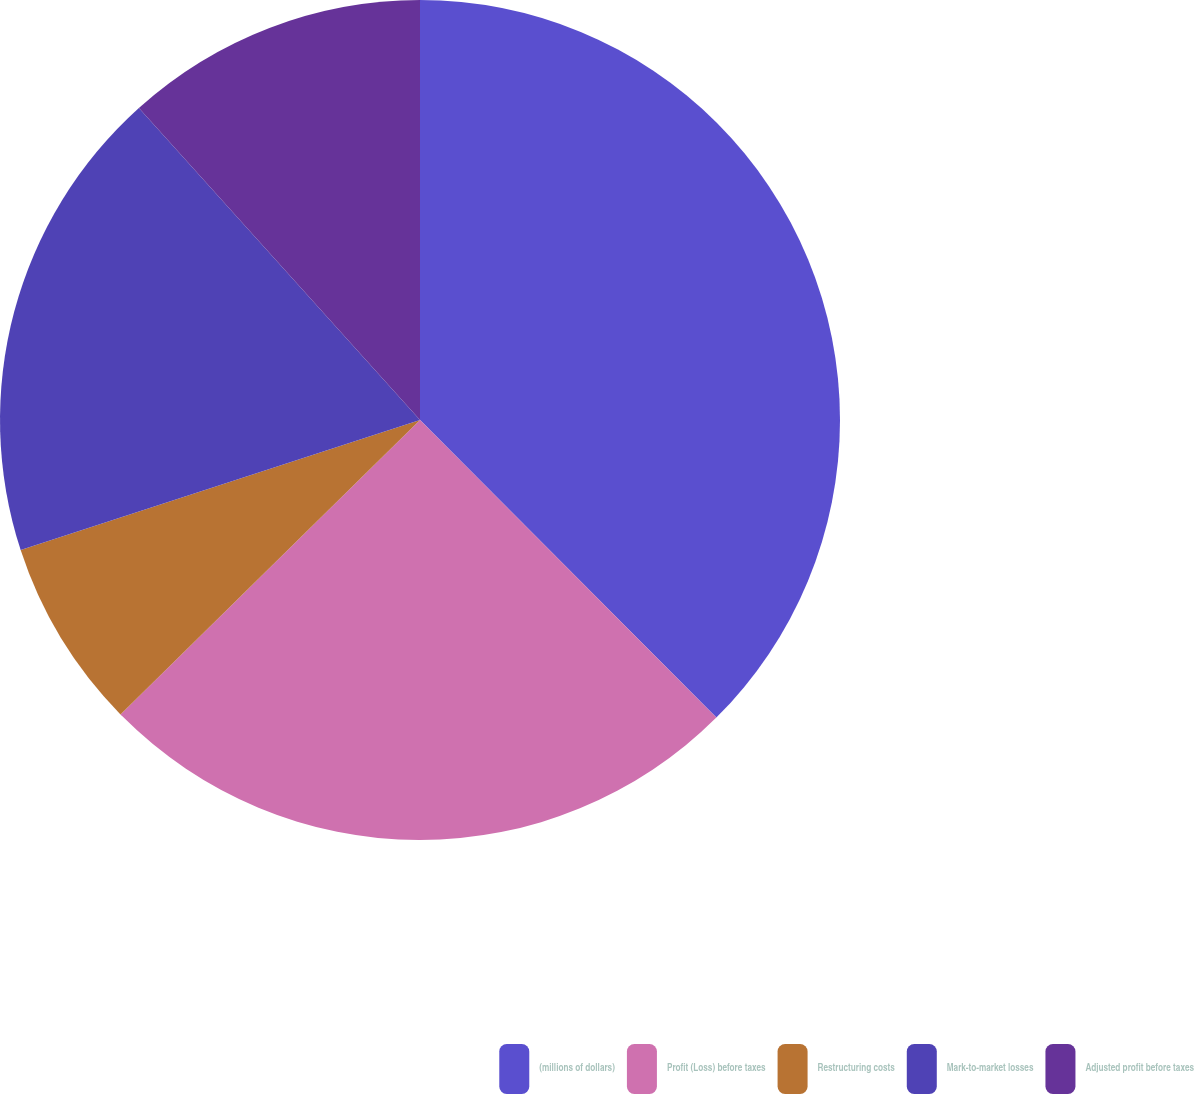Convert chart. <chart><loc_0><loc_0><loc_500><loc_500><pie_chart><fcel>(millions of dollars)<fcel>Profit (Loss) before taxes<fcel>Restructuring costs<fcel>Mark-to-market losses<fcel>Adjusted profit before taxes<nl><fcel>37.53%<fcel>25.1%<fcel>7.35%<fcel>18.34%<fcel>11.67%<nl></chart> 